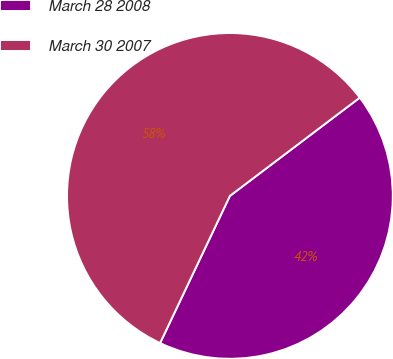<chart> <loc_0><loc_0><loc_500><loc_500><pie_chart><fcel>March 28 2008<fcel>March 30 2007<nl><fcel>42.36%<fcel>57.64%<nl></chart> 